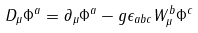Convert formula to latex. <formula><loc_0><loc_0><loc_500><loc_500>D _ { \mu } \Phi ^ { a } = \partial _ { \mu } \Phi ^ { a } - g \epsilon _ { a b c } W _ { \mu } ^ { b } \Phi ^ { c }</formula> 